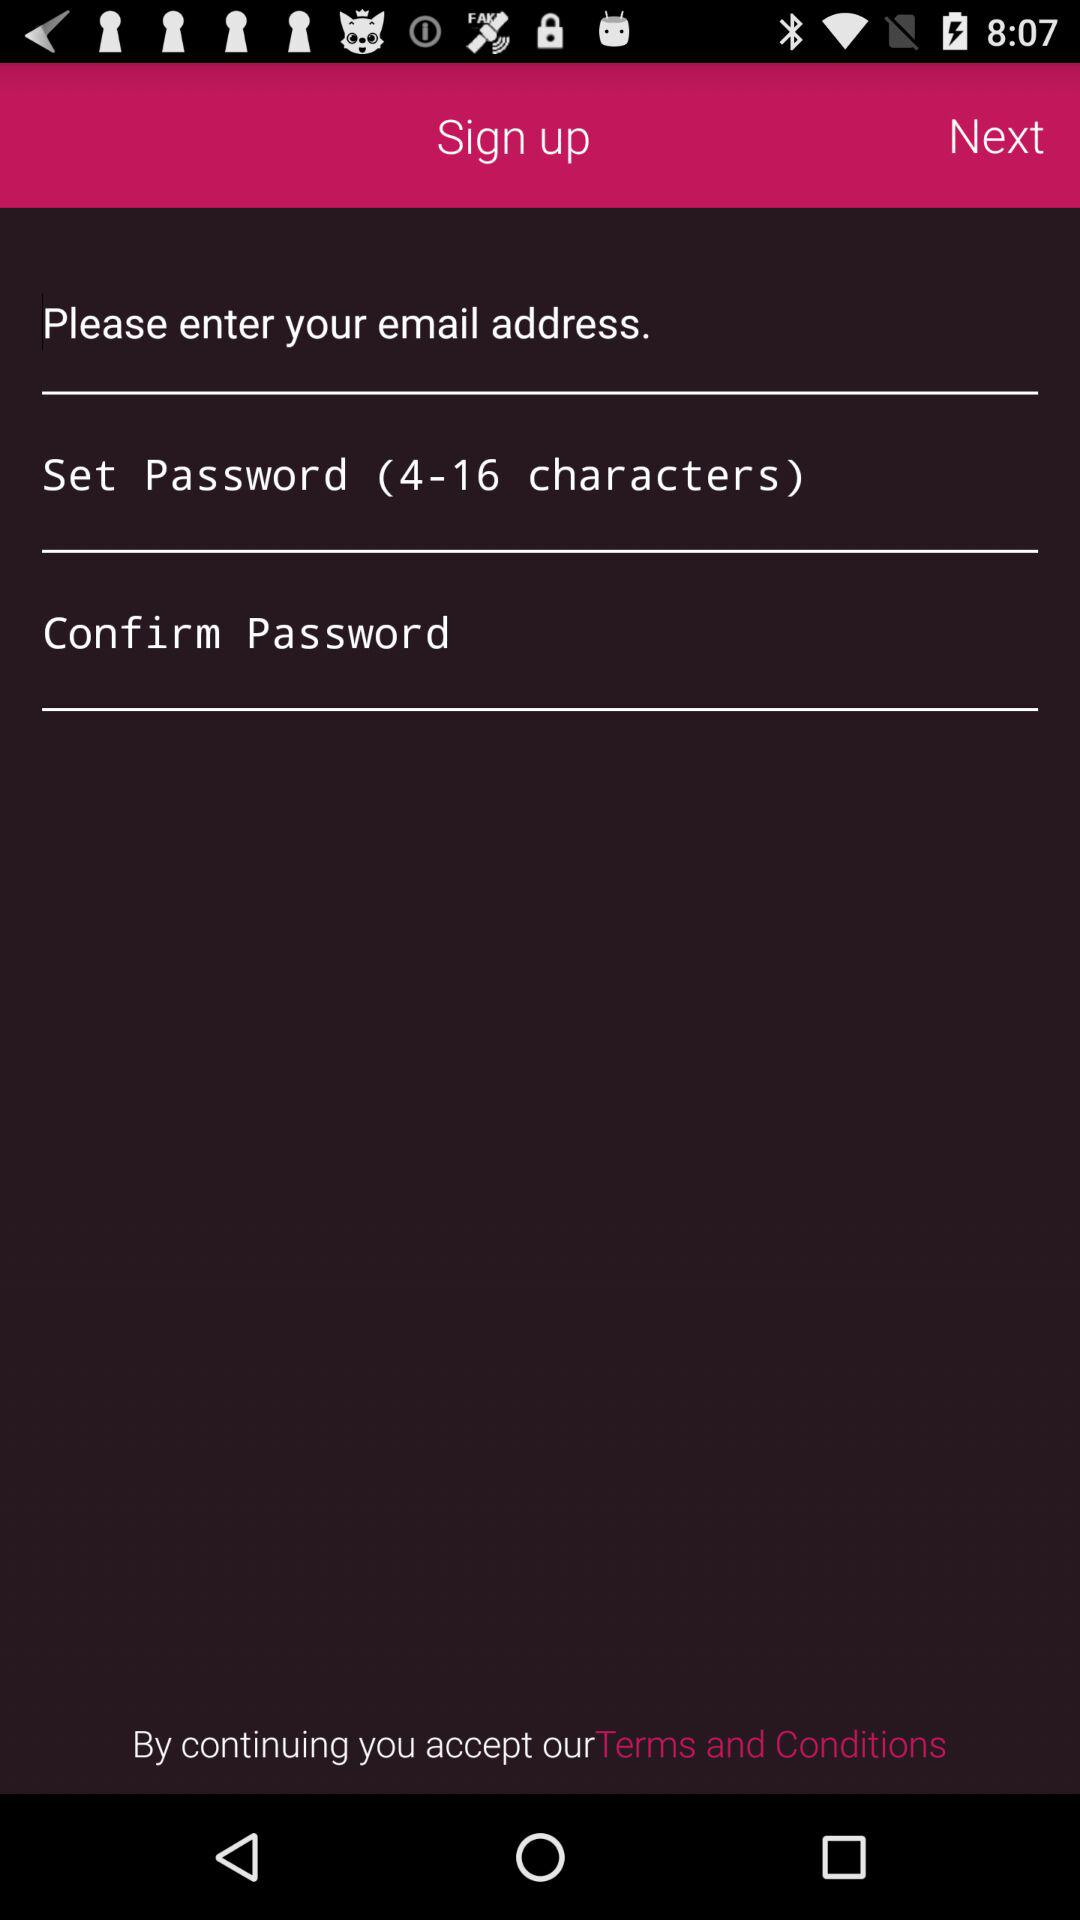How many characters should be in a password? There should be 4-16 characters in the password. 